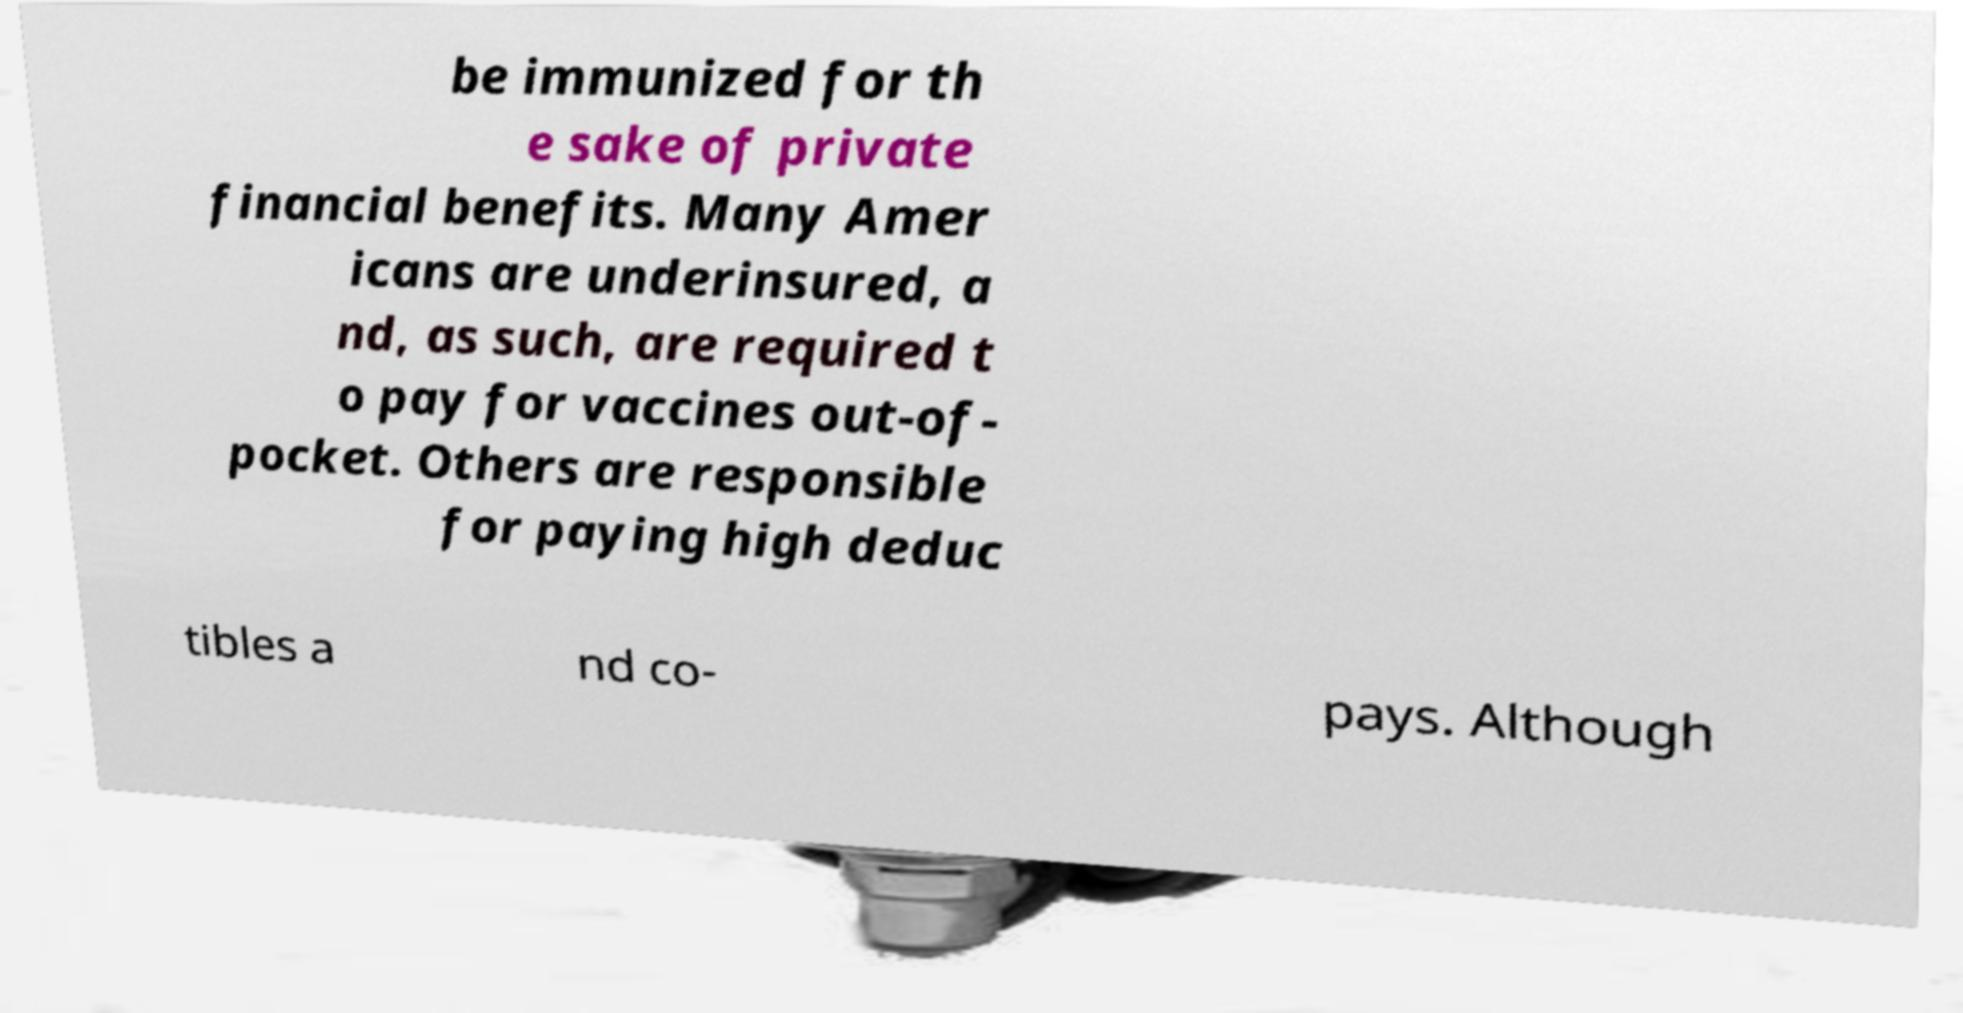Can you accurately transcribe the text from the provided image for me? be immunized for th e sake of private financial benefits. Many Amer icans are underinsured, a nd, as such, are required t o pay for vaccines out-of- pocket. Others are responsible for paying high deduc tibles a nd co- pays. Although 